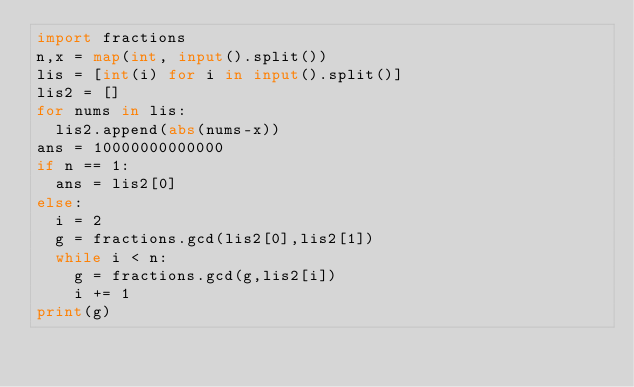Convert code to text. <code><loc_0><loc_0><loc_500><loc_500><_Python_>import fractions
n,x = map(int, input().split())
lis = [int(i) for i in input().split()]
lis2 = []
for nums in lis:
  lis2.append(abs(nums-x))
ans = 10000000000000
if n == 1:
  ans = lis2[0]
else:
  i = 2
  g = fractions.gcd(lis2[0],lis2[1])
  while i < n:
    g = fractions.gcd(g,lis2[i])
    i += 1
print(g)</code> 